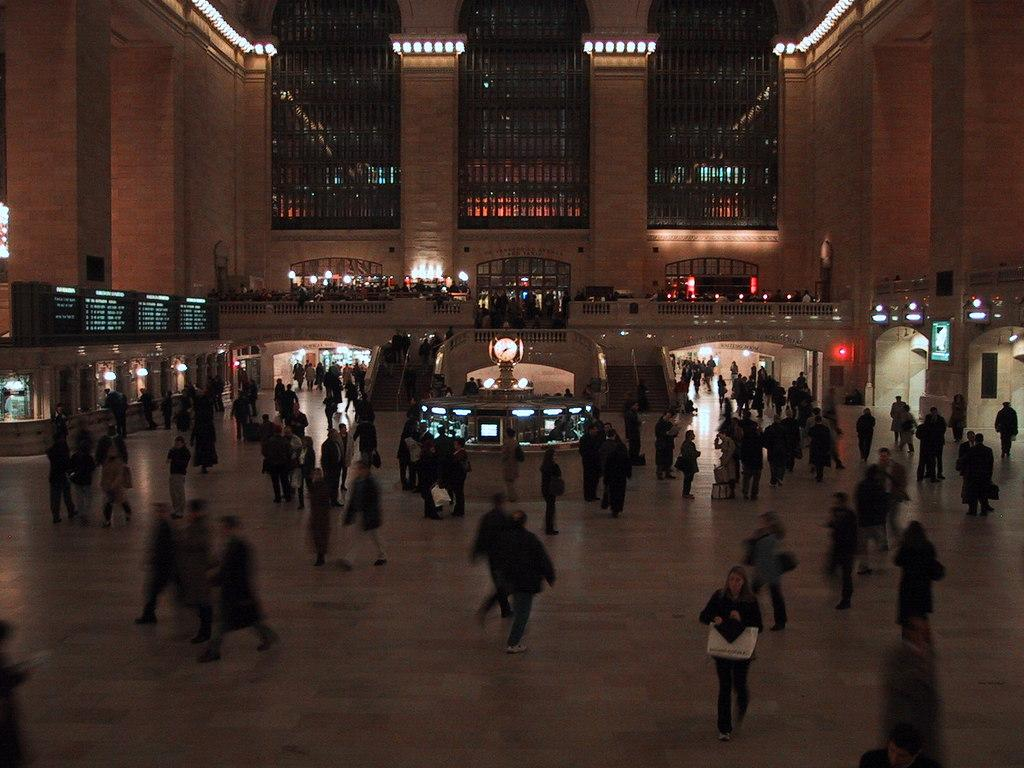How many people are in the image? There are persons in the image, but the exact number is not specified. What can be seen through the windows in the image? The facts do not specify what can be seen through the windows. What is the purpose of the computer in the image? The purpose of the computer in the image is not specified. What type of lighting is present in the image? There are lights in the image, but the specific type is not mentioned. What is visible on the floor in the image? The facts do not specify what is visible on the floor. What type of stores are in the image? The facts do not specify the type of stores in the image. What is being displayed on the display in the image? The facts do not specify what is being displayed on the display. How many doors are in the image? The facts do not specify the number of doors in the image. What is the purpose of the pillars in the image? The purpose of the pillars in the image is not specified. What is the wall made of in the image? The facts do not specify the material of the wall in the image. Can you tell me how many buttons are on the attention-grabbing horn in the image? There is no mention of a horn or buttons in the image. 